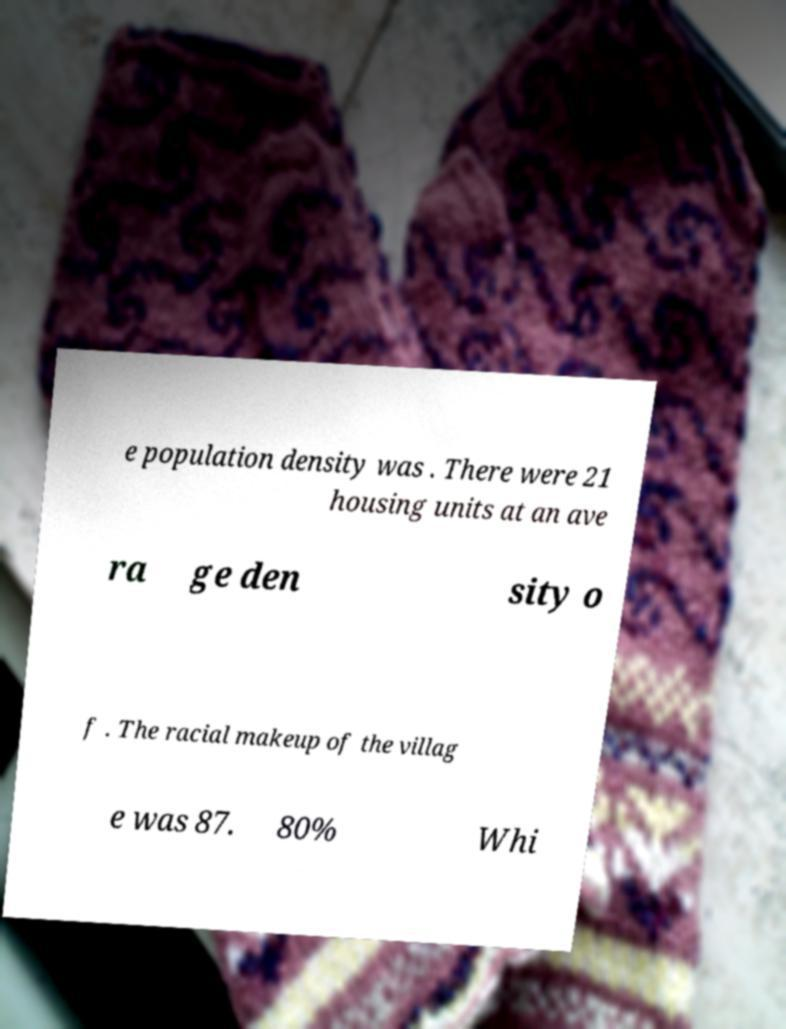For documentation purposes, I need the text within this image transcribed. Could you provide that? e population density was . There were 21 housing units at an ave ra ge den sity o f . The racial makeup of the villag e was 87. 80% Whi 